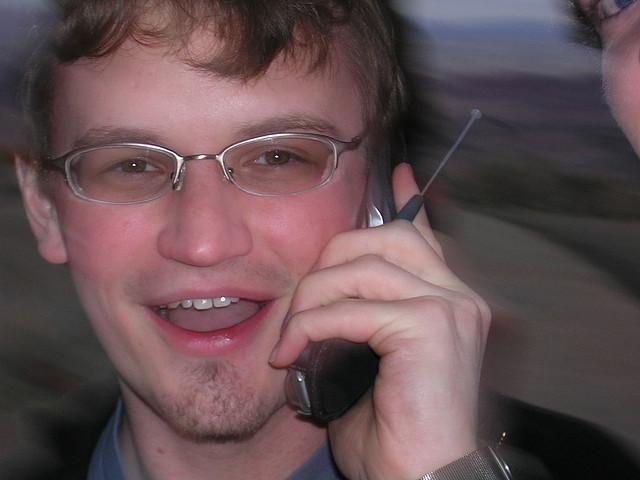How many sunglasses are covering his eyes?
Give a very brief answer. 0. How many phones does the man have?
Give a very brief answer. 1. How many people can you see?
Give a very brief answer. 2. 